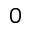<formula> <loc_0><loc_0><loc_500><loc_500>0</formula> 